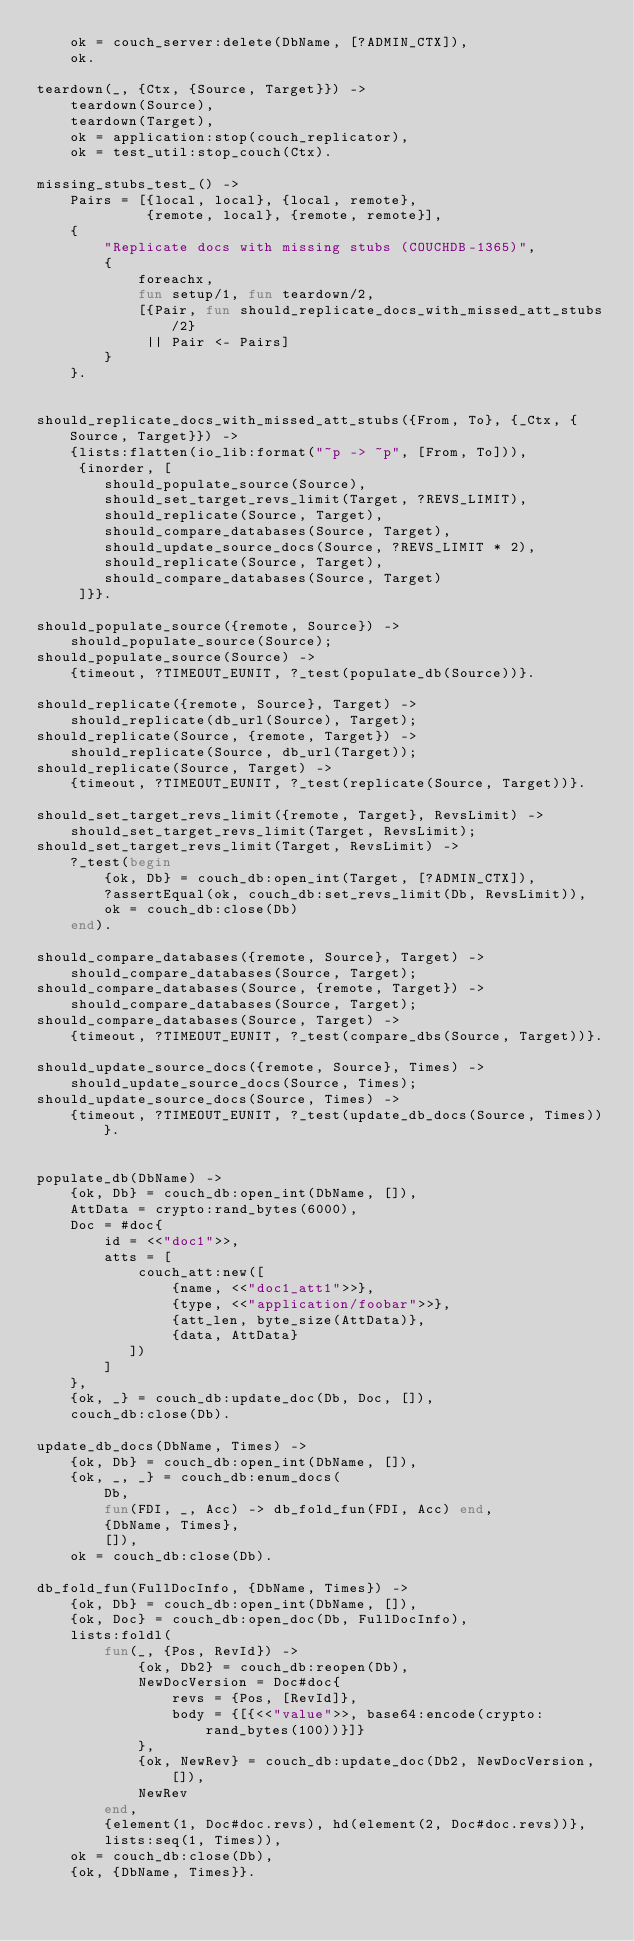<code> <loc_0><loc_0><loc_500><loc_500><_Erlang_>    ok = couch_server:delete(DbName, [?ADMIN_CTX]),
    ok.

teardown(_, {Ctx, {Source, Target}}) ->
    teardown(Source),
    teardown(Target),
    ok = application:stop(couch_replicator),
    ok = test_util:stop_couch(Ctx).

missing_stubs_test_() ->
    Pairs = [{local, local}, {local, remote},
             {remote, local}, {remote, remote}],
    {
        "Replicate docs with missing stubs (COUCHDB-1365)",
        {
            foreachx,
            fun setup/1, fun teardown/2,
            [{Pair, fun should_replicate_docs_with_missed_att_stubs/2}
             || Pair <- Pairs]
        }
    }.


should_replicate_docs_with_missed_att_stubs({From, To}, {_Ctx, {Source, Target}}) ->
    {lists:flatten(io_lib:format("~p -> ~p", [From, To])),
     {inorder, [
        should_populate_source(Source),
        should_set_target_revs_limit(Target, ?REVS_LIMIT),
        should_replicate(Source, Target),
        should_compare_databases(Source, Target),
        should_update_source_docs(Source, ?REVS_LIMIT * 2),
        should_replicate(Source, Target),
        should_compare_databases(Source, Target)
     ]}}.

should_populate_source({remote, Source}) ->
    should_populate_source(Source);
should_populate_source(Source) ->
    {timeout, ?TIMEOUT_EUNIT, ?_test(populate_db(Source))}.

should_replicate({remote, Source}, Target) ->
    should_replicate(db_url(Source), Target);
should_replicate(Source, {remote, Target}) ->
    should_replicate(Source, db_url(Target));
should_replicate(Source, Target) ->
    {timeout, ?TIMEOUT_EUNIT, ?_test(replicate(Source, Target))}.

should_set_target_revs_limit({remote, Target}, RevsLimit) ->
    should_set_target_revs_limit(Target, RevsLimit);
should_set_target_revs_limit(Target, RevsLimit) ->
    ?_test(begin
        {ok, Db} = couch_db:open_int(Target, [?ADMIN_CTX]),
        ?assertEqual(ok, couch_db:set_revs_limit(Db, RevsLimit)),
        ok = couch_db:close(Db)
    end).

should_compare_databases({remote, Source}, Target) ->
    should_compare_databases(Source, Target);
should_compare_databases(Source, {remote, Target}) ->
    should_compare_databases(Source, Target);
should_compare_databases(Source, Target) ->
    {timeout, ?TIMEOUT_EUNIT, ?_test(compare_dbs(Source, Target))}.

should_update_source_docs({remote, Source}, Times) ->
    should_update_source_docs(Source, Times);
should_update_source_docs(Source, Times) ->
    {timeout, ?TIMEOUT_EUNIT, ?_test(update_db_docs(Source, Times))}.


populate_db(DbName) ->
    {ok, Db} = couch_db:open_int(DbName, []),
    AttData = crypto:rand_bytes(6000),
    Doc = #doc{
        id = <<"doc1">>,
        atts = [
            couch_att:new([
                {name, <<"doc1_att1">>},
                {type, <<"application/foobar">>},
                {att_len, byte_size(AttData)},
                {data, AttData}
           ])
        ]
    },
    {ok, _} = couch_db:update_doc(Db, Doc, []),
    couch_db:close(Db).

update_db_docs(DbName, Times) ->
    {ok, Db} = couch_db:open_int(DbName, []),
    {ok, _, _} = couch_db:enum_docs(
        Db,
        fun(FDI, _, Acc) -> db_fold_fun(FDI, Acc) end,
        {DbName, Times},
        []),
    ok = couch_db:close(Db).

db_fold_fun(FullDocInfo, {DbName, Times}) ->
    {ok, Db} = couch_db:open_int(DbName, []),
    {ok, Doc} = couch_db:open_doc(Db, FullDocInfo),
    lists:foldl(
        fun(_, {Pos, RevId}) ->
            {ok, Db2} = couch_db:reopen(Db),
            NewDocVersion = Doc#doc{
                revs = {Pos, [RevId]},
                body = {[{<<"value">>, base64:encode(crypto:rand_bytes(100))}]}
            },
            {ok, NewRev} = couch_db:update_doc(Db2, NewDocVersion, []),
            NewRev
        end,
        {element(1, Doc#doc.revs), hd(element(2, Doc#doc.revs))},
        lists:seq(1, Times)),
    ok = couch_db:close(Db),
    {ok, {DbName, Times}}.
</code> 